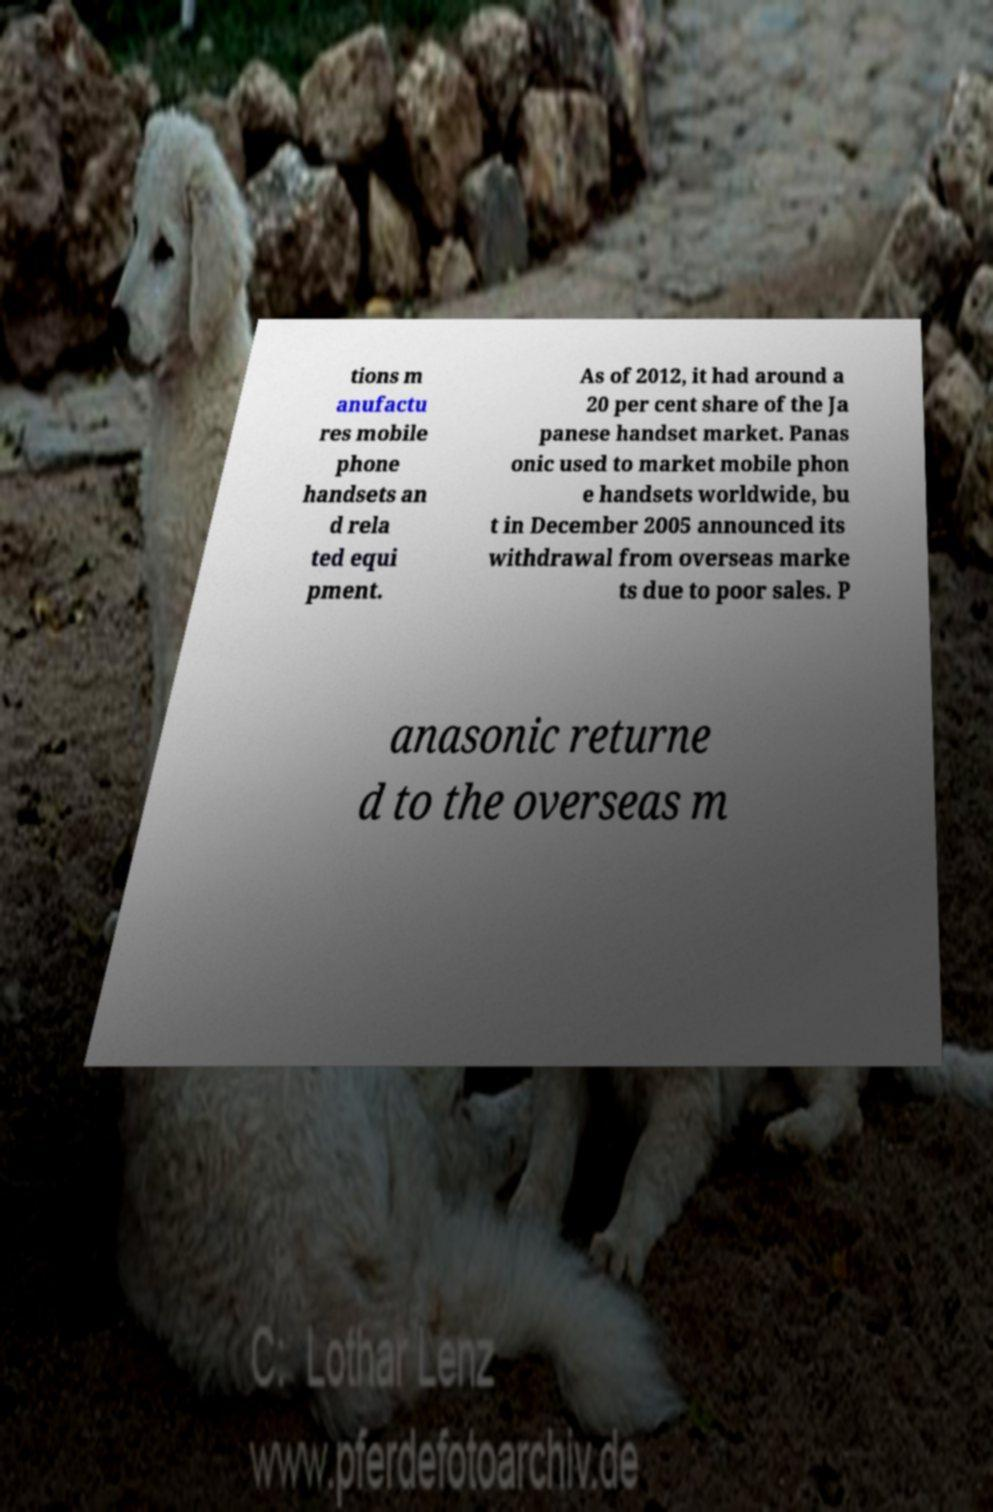Can you accurately transcribe the text from the provided image for me? tions m anufactu res mobile phone handsets an d rela ted equi pment. As of 2012, it had around a 20 per cent share of the Ja panese handset market. Panas onic used to market mobile phon e handsets worldwide, bu t in December 2005 announced its withdrawal from overseas marke ts due to poor sales. P anasonic returne d to the overseas m 